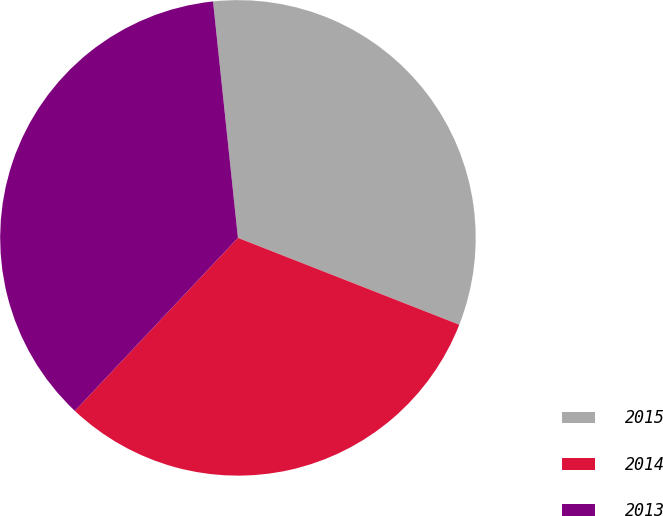<chart> <loc_0><loc_0><loc_500><loc_500><pie_chart><fcel>2015<fcel>2014<fcel>2013<nl><fcel>32.62%<fcel>31.08%<fcel>36.3%<nl></chart> 